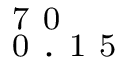<formula> <loc_0><loc_0><loc_500><loc_500>_ { 0 } . 1 5 ^ { 7 0 }</formula> 